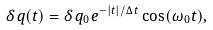<formula> <loc_0><loc_0><loc_500><loc_500>\delta \, q ( t ) = \delta \, q _ { 0 } e ^ { - | t | / \Delta \, t } \cos ( \omega _ { 0 } t ) ,</formula> 